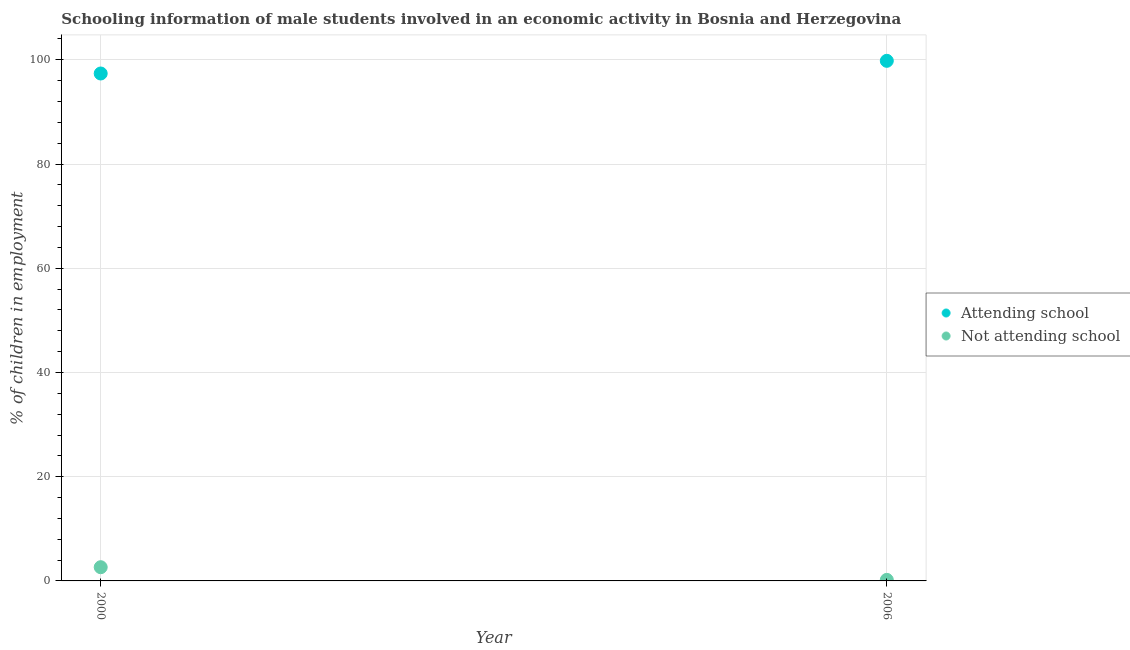What is the percentage of employed males who are not attending school in 2000?
Provide a short and direct response. 2.63. Across all years, what is the maximum percentage of employed males who are not attending school?
Provide a succinct answer. 2.63. What is the total percentage of employed males who are attending school in the graph?
Your answer should be compact. 197.17. What is the difference between the percentage of employed males who are attending school in 2000 and that in 2006?
Keep it short and to the point. -2.43. What is the difference between the percentage of employed males who are not attending school in 2006 and the percentage of employed males who are attending school in 2000?
Your answer should be very brief. -97.17. What is the average percentage of employed males who are not attending school per year?
Offer a very short reply. 1.42. In the year 2006, what is the difference between the percentage of employed males who are not attending school and percentage of employed males who are attending school?
Offer a very short reply. -99.6. What is the ratio of the percentage of employed males who are not attending school in 2000 to that in 2006?
Your answer should be compact. 13.16. Does the percentage of employed males who are not attending school monotonically increase over the years?
Ensure brevity in your answer.  No. Is the percentage of employed males who are attending school strictly greater than the percentage of employed males who are not attending school over the years?
Your answer should be very brief. Yes. Are the values on the major ticks of Y-axis written in scientific E-notation?
Your answer should be compact. No. Does the graph contain grids?
Your answer should be compact. Yes. How are the legend labels stacked?
Your answer should be compact. Vertical. What is the title of the graph?
Give a very brief answer. Schooling information of male students involved in an economic activity in Bosnia and Herzegovina. What is the label or title of the Y-axis?
Offer a very short reply. % of children in employment. What is the % of children in employment in Attending school in 2000?
Your answer should be compact. 97.37. What is the % of children in employment in Not attending school in 2000?
Keep it short and to the point. 2.63. What is the % of children in employment in Attending school in 2006?
Your answer should be very brief. 99.8. What is the % of children in employment in Not attending school in 2006?
Ensure brevity in your answer.  0.2. Across all years, what is the maximum % of children in employment in Attending school?
Your answer should be very brief. 99.8. Across all years, what is the maximum % of children in employment in Not attending school?
Offer a very short reply. 2.63. Across all years, what is the minimum % of children in employment in Attending school?
Offer a terse response. 97.37. What is the total % of children in employment of Attending school in the graph?
Keep it short and to the point. 197.17. What is the total % of children in employment of Not attending school in the graph?
Your response must be concise. 2.83. What is the difference between the % of children in employment in Attending school in 2000 and that in 2006?
Make the answer very short. -2.43. What is the difference between the % of children in employment in Not attending school in 2000 and that in 2006?
Offer a terse response. 2.43. What is the difference between the % of children in employment in Attending school in 2000 and the % of children in employment in Not attending school in 2006?
Give a very brief answer. 97.17. What is the average % of children in employment of Attending school per year?
Ensure brevity in your answer.  98.58. What is the average % of children in employment in Not attending school per year?
Offer a terse response. 1.42. In the year 2000, what is the difference between the % of children in employment in Attending school and % of children in employment in Not attending school?
Your answer should be compact. 94.74. In the year 2006, what is the difference between the % of children in employment in Attending school and % of children in employment in Not attending school?
Offer a very short reply. 99.6. What is the ratio of the % of children in employment in Attending school in 2000 to that in 2006?
Offer a very short reply. 0.98. What is the ratio of the % of children in employment of Not attending school in 2000 to that in 2006?
Provide a succinct answer. 13.16. What is the difference between the highest and the second highest % of children in employment in Attending school?
Give a very brief answer. 2.43. What is the difference between the highest and the second highest % of children in employment of Not attending school?
Keep it short and to the point. 2.43. What is the difference between the highest and the lowest % of children in employment of Attending school?
Provide a succinct answer. 2.43. What is the difference between the highest and the lowest % of children in employment of Not attending school?
Make the answer very short. 2.43. 